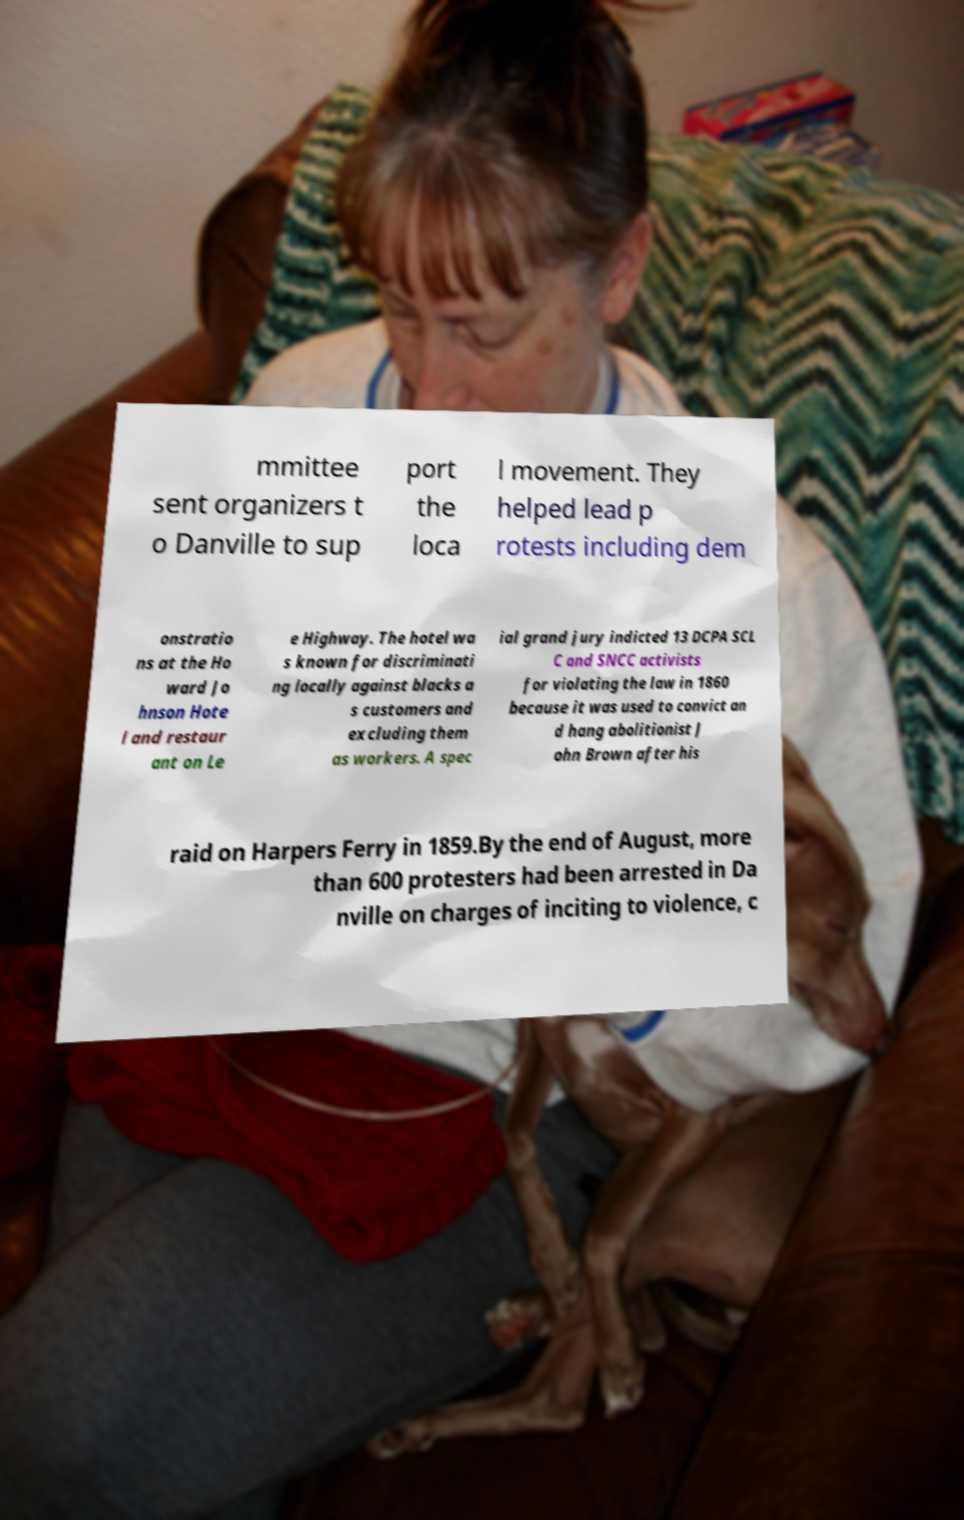For documentation purposes, I need the text within this image transcribed. Could you provide that? mmittee sent organizers t o Danville to sup port the loca l movement. They helped lead p rotests including dem onstratio ns at the Ho ward Jo hnson Hote l and restaur ant on Le e Highway. The hotel wa s known for discriminati ng locally against blacks a s customers and excluding them as workers. A spec ial grand jury indicted 13 DCPA SCL C and SNCC activists for violating the law in 1860 because it was used to convict an d hang abolitionist J ohn Brown after his raid on Harpers Ferry in 1859.By the end of August, more than 600 protesters had been arrested in Da nville on charges of inciting to violence, c 